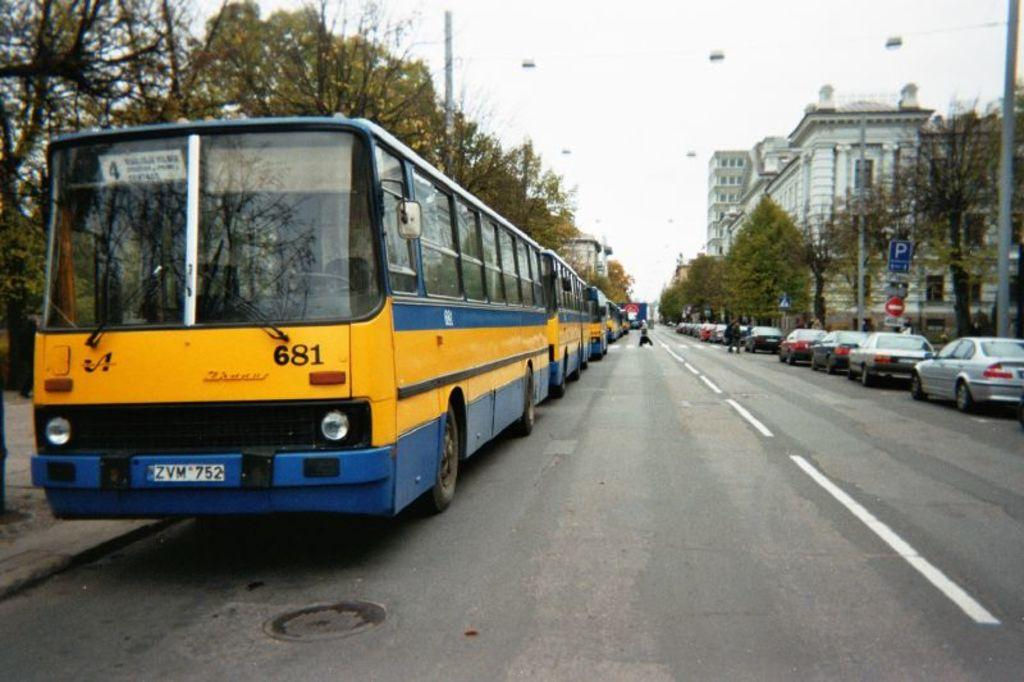What can be seen on the road in the image? There are vehicles and persons on the road in the image. What structures are present beside the road? There are poles, sign boards, trees, and buildings beside the road. Can you see a cow wearing a collar in the image? No, there is no cow wearing a collar in the image. 